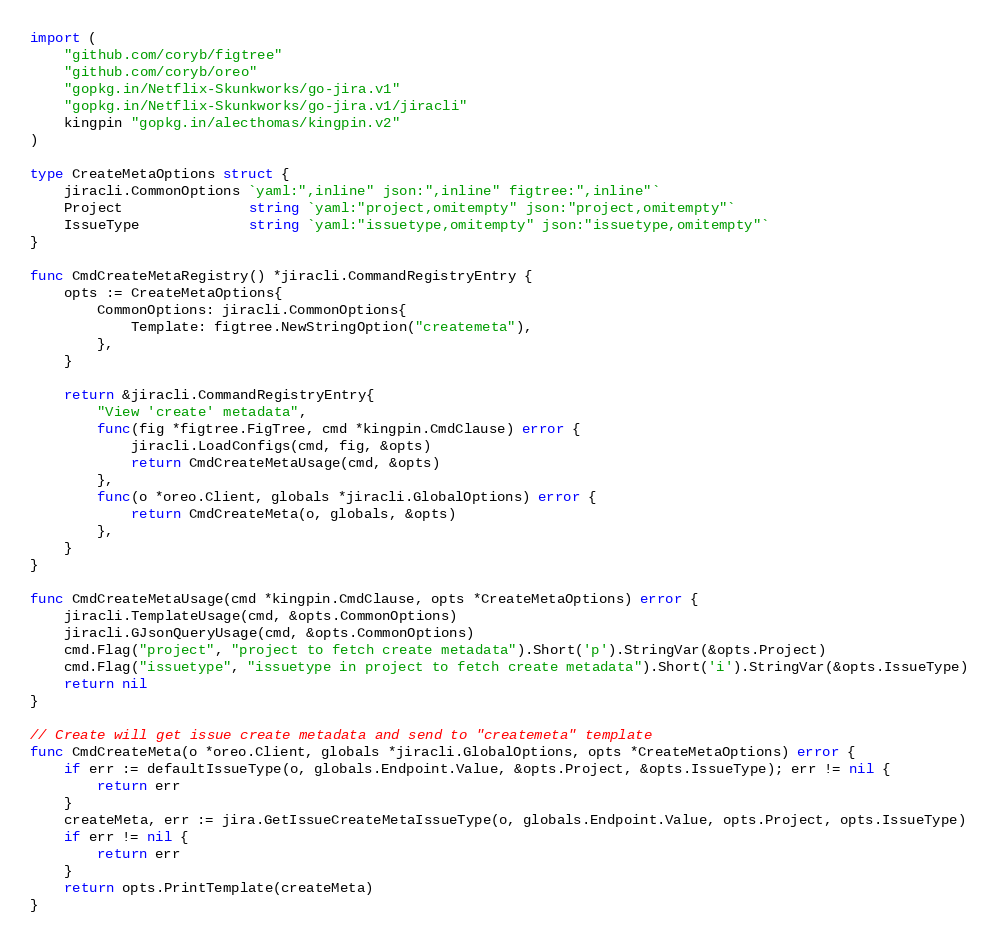Convert code to text. <code><loc_0><loc_0><loc_500><loc_500><_Go_>import (
	"github.com/coryb/figtree"
	"github.com/coryb/oreo"
	"gopkg.in/Netflix-Skunkworks/go-jira.v1"
	"gopkg.in/Netflix-Skunkworks/go-jira.v1/jiracli"
	kingpin "gopkg.in/alecthomas/kingpin.v2"
)

type CreateMetaOptions struct {
	jiracli.CommonOptions `yaml:",inline" json:",inline" figtree:",inline"`
	Project               string `yaml:"project,omitempty" json:"project,omitempty"`
	IssueType             string `yaml:"issuetype,omitempty" json:"issuetype,omitempty"`
}

func CmdCreateMetaRegistry() *jiracli.CommandRegistryEntry {
	opts := CreateMetaOptions{
		CommonOptions: jiracli.CommonOptions{
			Template: figtree.NewStringOption("createmeta"),
		},
	}

	return &jiracli.CommandRegistryEntry{
		"View 'create' metadata",
		func(fig *figtree.FigTree, cmd *kingpin.CmdClause) error {
			jiracli.LoadConfigs(cmd, fig, &opts)
			return CmdCreateMetaUsage(cmd, &opts)
		},
		func(o *oreo.Client, globals *jiracli.GlobalOptions) error {
			return CmdCreateMeta(o, globals, &opts)
		},
	}
}

func CmdCreateMetaUsage(cmd *kingpin.CmdClause, opts *CreateMetaOptions) error {
	jiracli.TemplateUsage(cmd, &opts.CommonOptions)
	jiracli.GJsonQueryUsage(cmd, &opts.CommonOptions)
	cmd.Flag("project", "project to fetch create metadata").Short('p').StringVar(&opts.Project)
	cmd.Flag("issuetype", "issuetype in project to fetch create metadata").Short('i').StringVar(&opts.IssueType)
	return nil
}

// Create will get issue create metadata and send to "createmeta" template
func CmdCreateMeta(o *oreo.Client, globals *jiracli.GlobalOptions, opts *CreateMetaOptions) error {
	if err := defaultIssueType(o, globals.Endpoint.Value, &opts.Project, &opts.IssueType); err != nil {
		return err
	}
	createMeta, err := jira.GetIssueCreateMetaIssueType(o, globals.Endpoint.Value, opts.Project, opts.IssueType)
	if err != nil {
		return err
	}
	return opts.PrintTemplate(createMeta)
}
</code> 